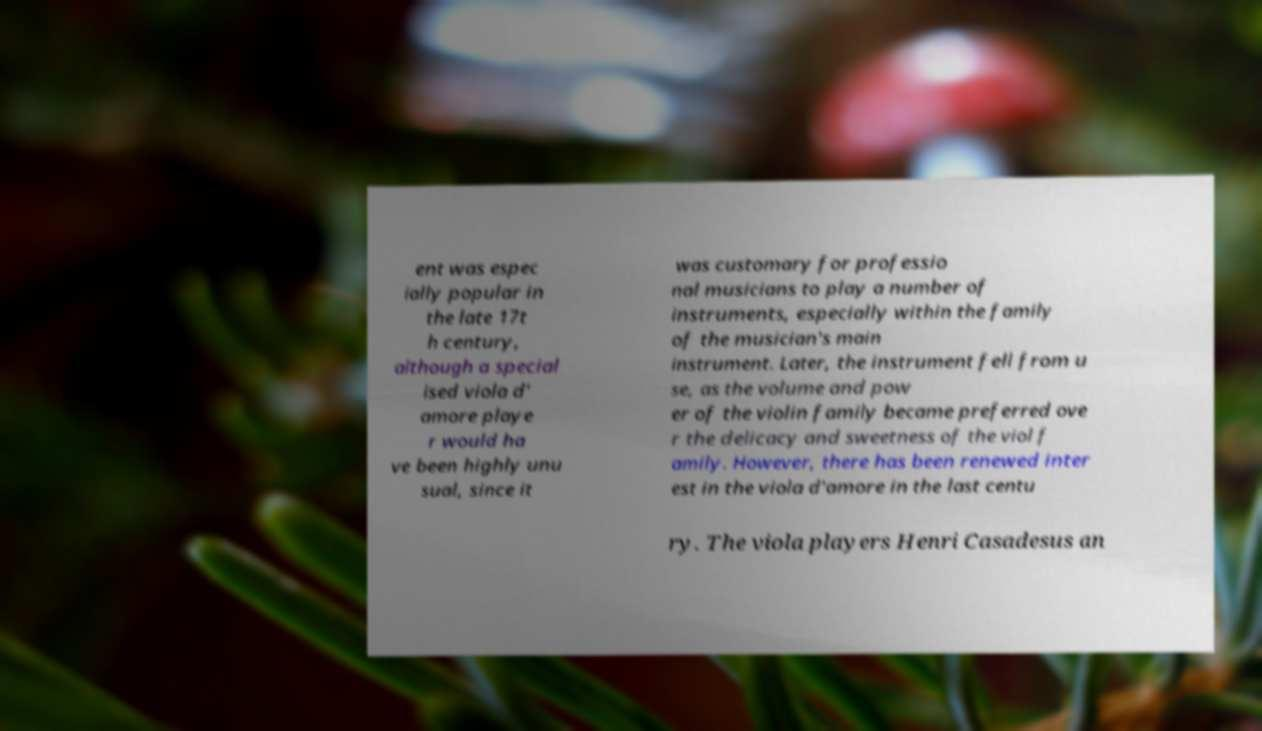For documentation purposes, I need the text within this image transcribed. Could you provide that? ent was espec ially popular in the late 17t h century, although a special ised viola d' amore playe r would ha ve been highly unu sual, since it was customary for professio nal musicians to play a number of instruments, especially within the family of the musician's main instrument. Later, the instrument fell from u se, as the volume and pow er of the violin family became preferred ove r the delicacy and sweetness of the viol f amily. However, there has been renewed inter est in the viola d'amore in the last centu ry. The viola players Henri Casadesus an 